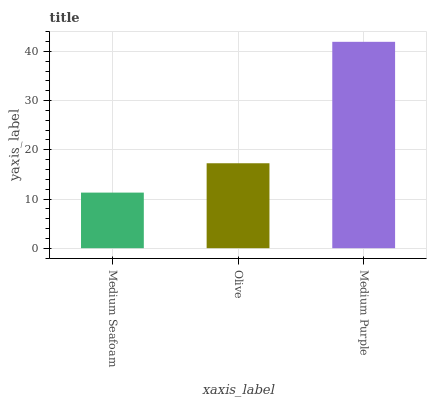Is Olive the minimum?
Answer yes or no. No. Is Olive the maximum?
Answer yes or no. No. Is Olive greater than Medium Seafoam?
Answer yes or no. Yes. Is Medium Seafoam less than Olive?
Answer yes or no. Yes. Is Medium Seafoam greater than Olive?
Answer yes or no. No. Is Olive less than Medium Seafoam?
Answer yes or no. No. Is Olive the high median?
Answer yes or no. Yes. Is Olive the low median?
Answer yes or no. Yes. Is Medium Purple the high median?
Answer yes or no. No. Is Medium Purple the low median?
Answer yes or no. No. 